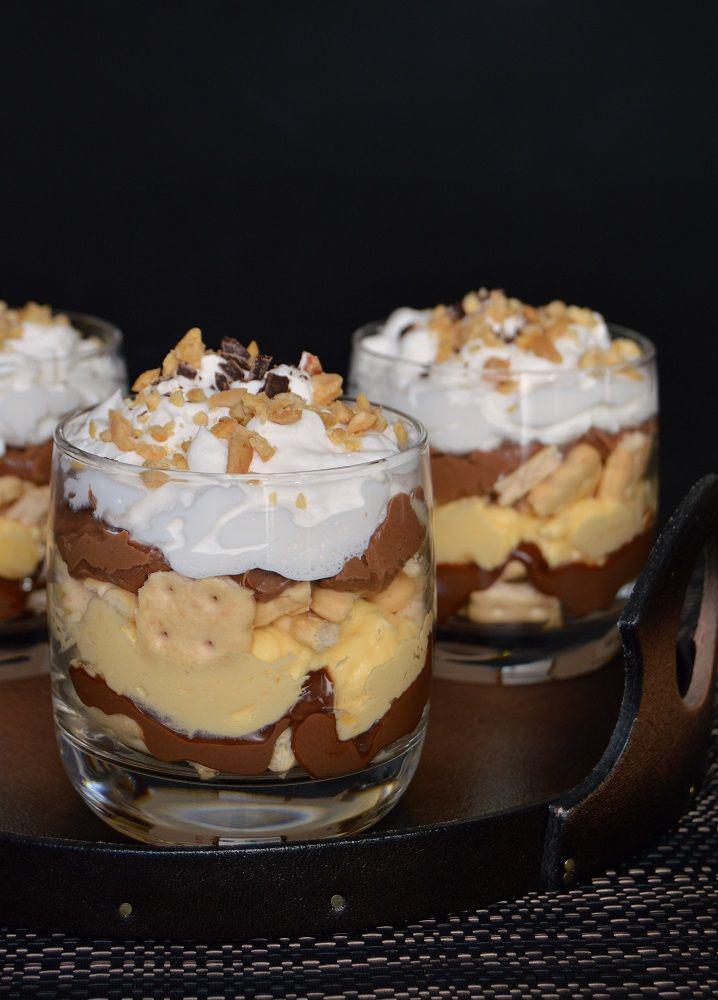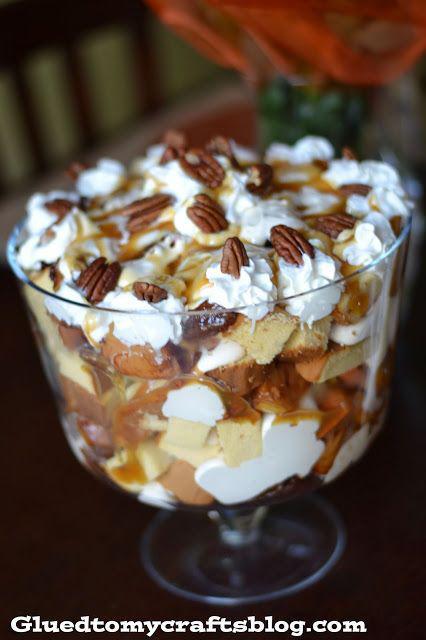The first image is the image on the left, the second image is the image on the right. For the images displayed, is the sentence "There are three cups of dessert in the image on the left." factually correct? Answer yes or no. Yes. The first image is the image on the left, the second image is the image on the right. For the images shown, is this caption "One image shows a large dessert in a clear glass footed bowl, while the second image shows three individual layered desserts in glasses." true? Answer yes or no. Yes. 